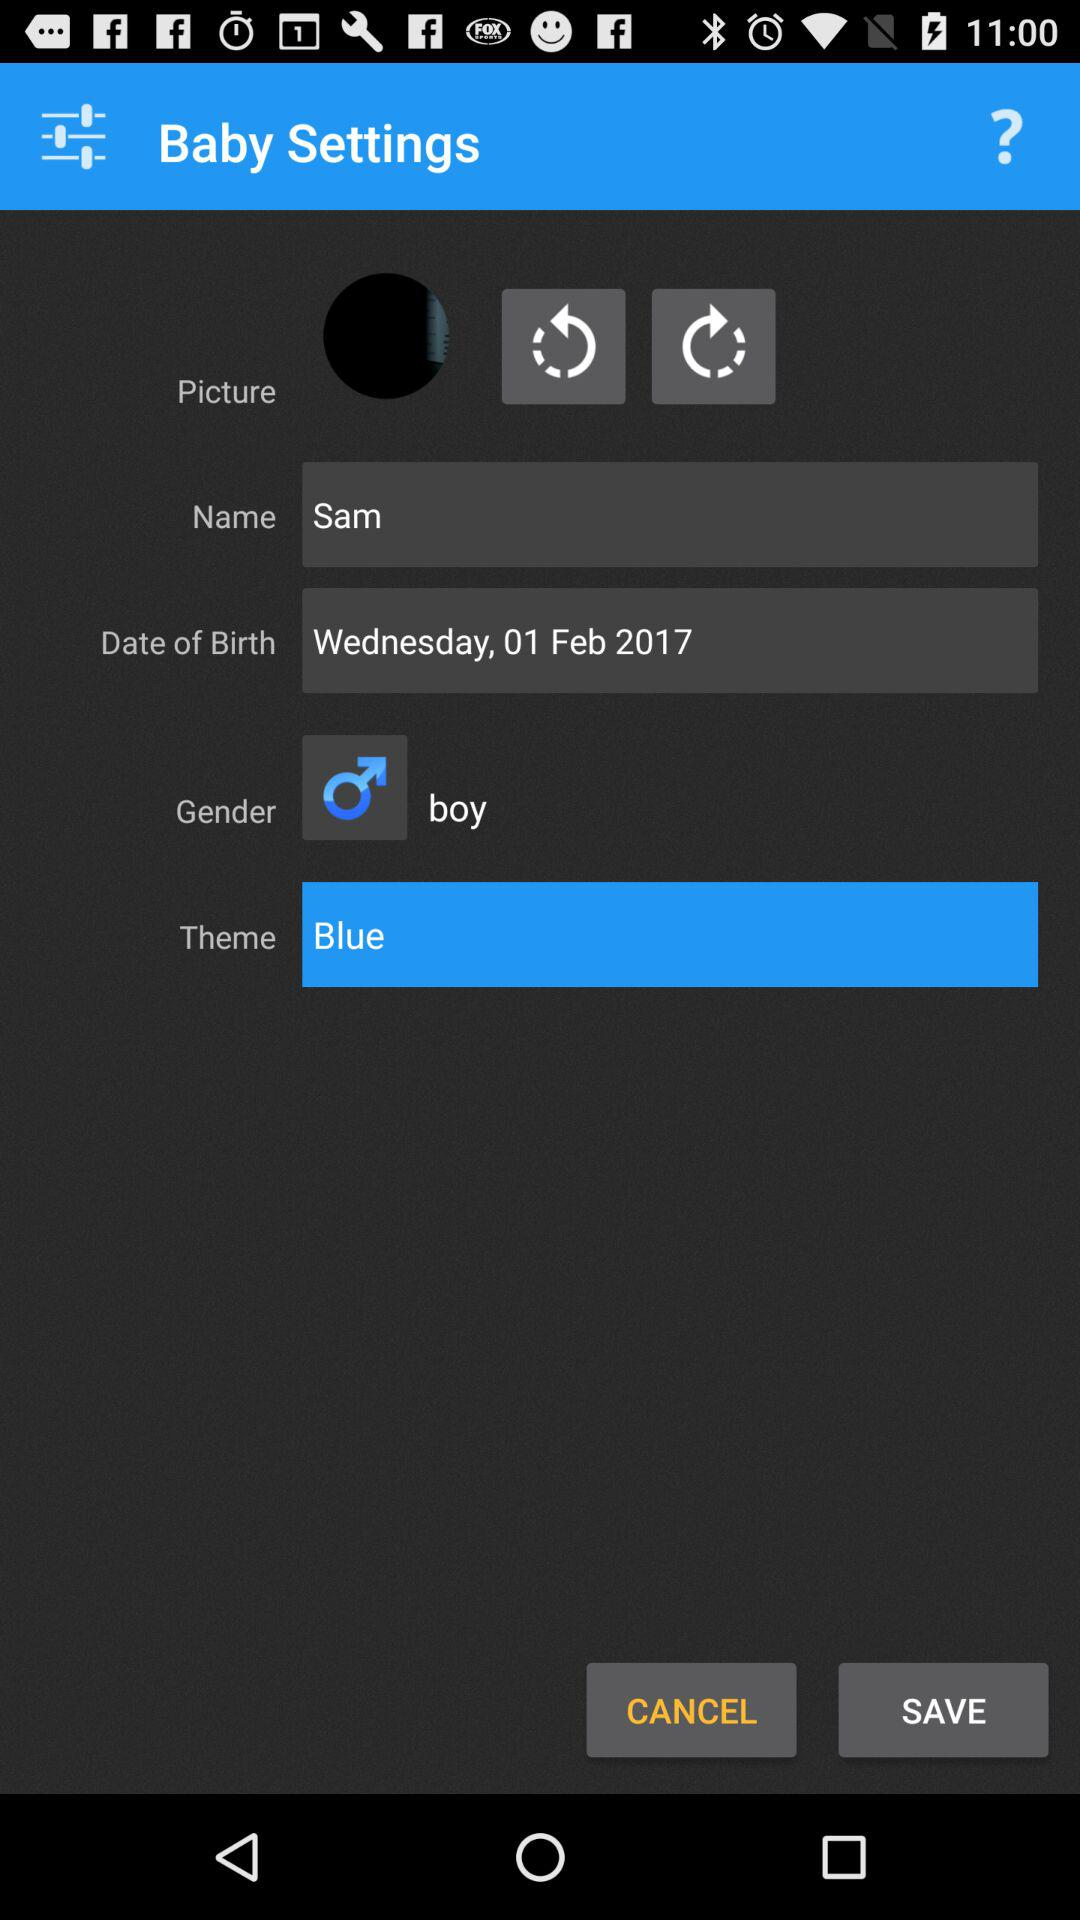What is the selected theme? The selected theme is blue. 